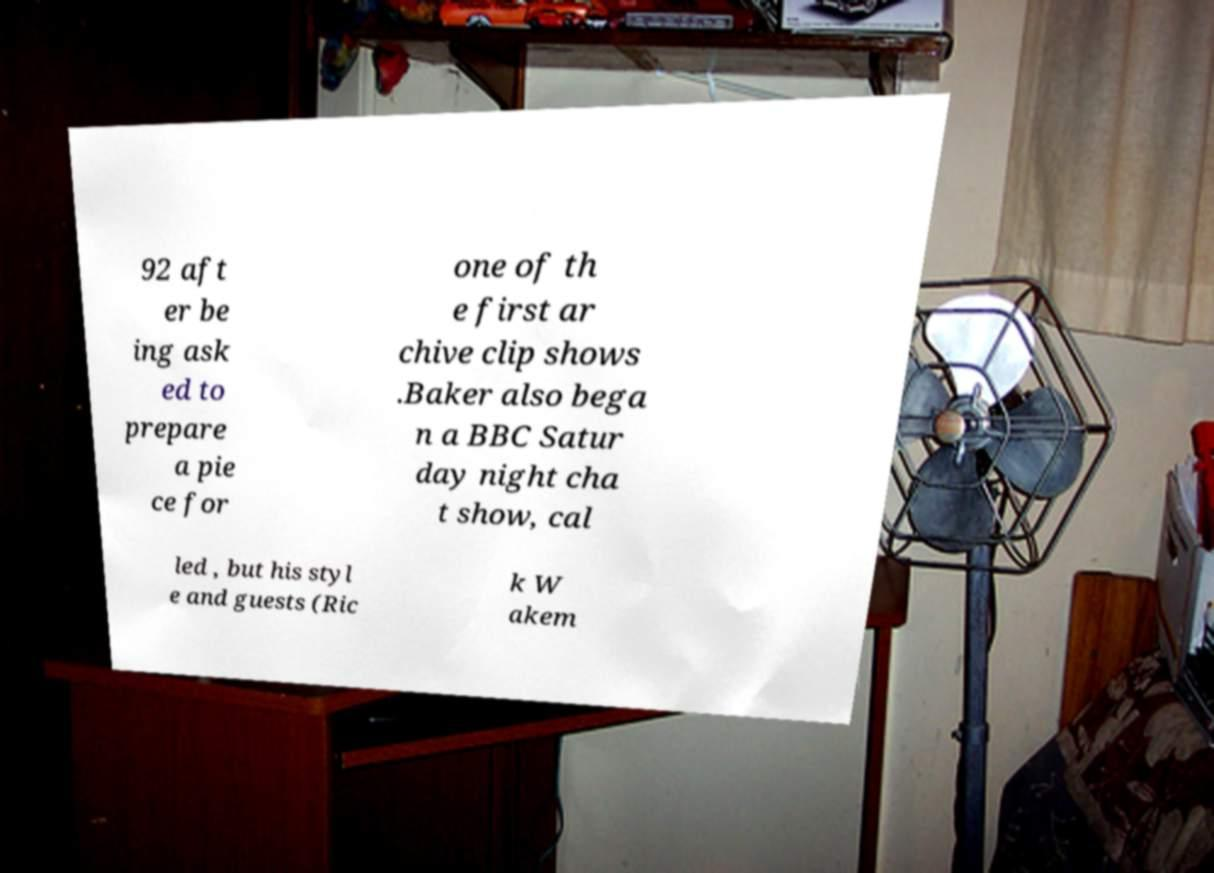I need the written content from this picture converted into text. Can you do that? 92 aft er be ing ask ed to prepare a pie ce for one of th e first ar chive clip shows .Baker also bega n a BBC Satur day night cha t show, cal led , but his styl e and guests (Ric k W akem 